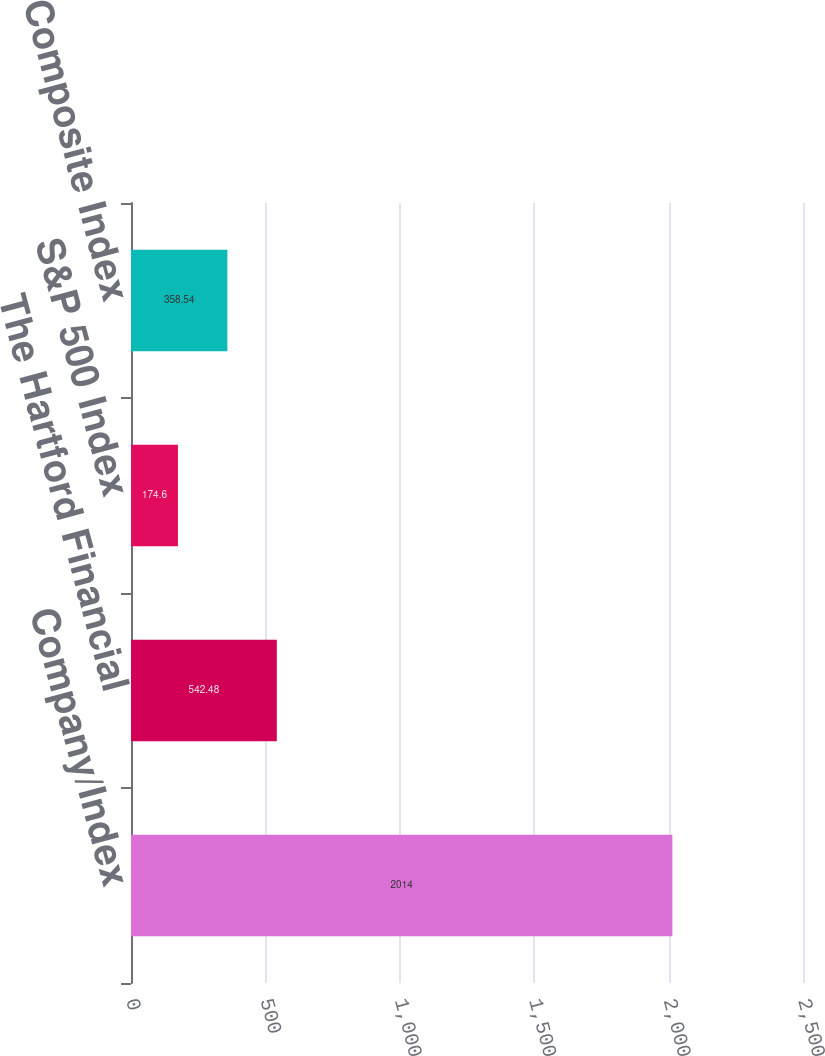<chart> <loc_0><loc_0><loc_500><loc_500><bar_chart><fcel>Company/Index<fcel>The Hartford Financial<fcel>S&P 500 Index<fcel>S&P Insurance Composite Index<nl><fcel>2014<fcel>542.48<fcel>174.6<fcel>358.54<nl></chart> 